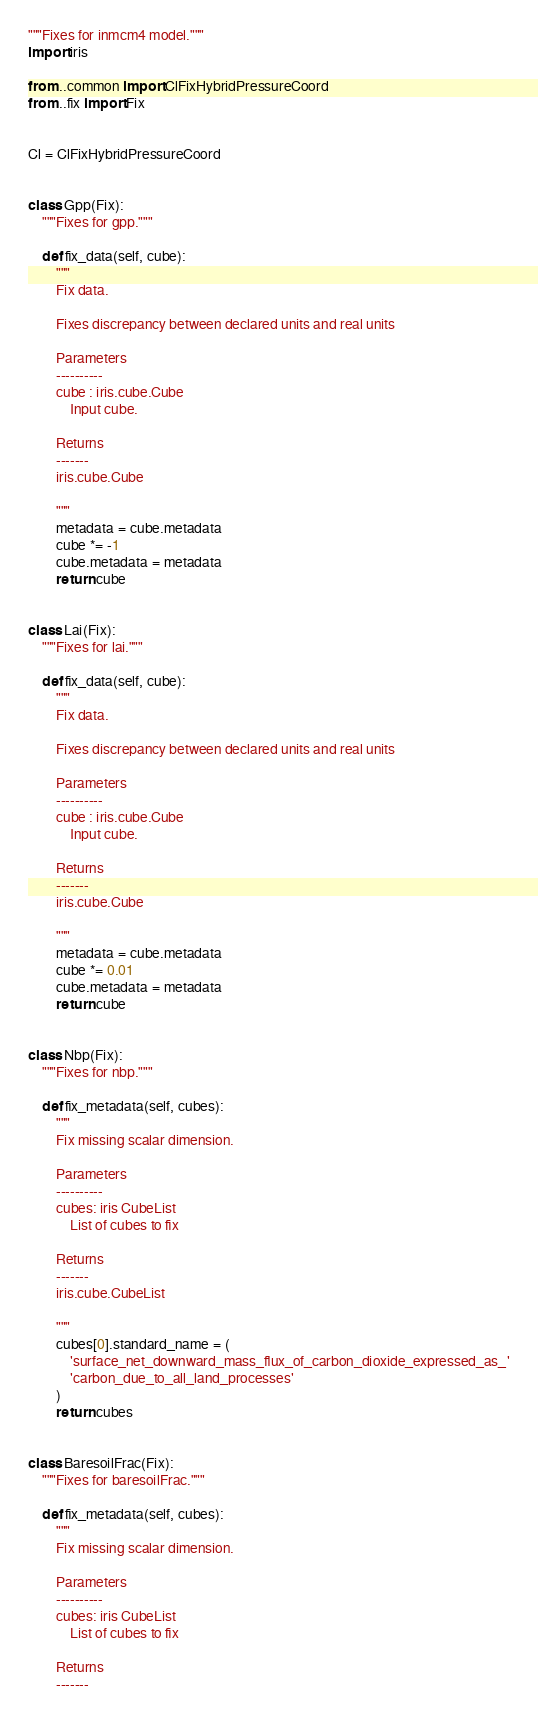<code> <loc_0><loc_0><loc_500><loc_500><_Python_>"""Fixes for inmcm4 model."""
import iris

from ..common import ClFixHybridPressureCoord
from ..fix import Fix


Cl = ClFixHybridPressureCoord


class Gpp(Fix):
    """Fixes for gpp."""

    def fix_data(self, cube):
        """
        Fix data.

        Fixes discrepancy between declared units and real units

        Parameters
        ----------
        cube : iris.cube.Cube
            Input cube.

        Returns
        -------
        iris.cube.Cube

        """
        metadata = cube.metadata
        cube *= -1
        cube.metadata = metadata
        return cube


class Lai(Fix):
    """Fixes for lai."""

    def fix_data(self, cube):
        """
        Fix data.

        Fixes discrepancy between declared units and real units

        Parameters
        ----------
        cube : iris.cube.Cube
            Input cube.

        Returns
        -------
        iris.cube.Cube

        """
        metadata = cube.metadata
        cube *= 0.01
        cube.metadata = metadata
        return cube


class Nbp(Fix):
    """Fixes for nbp."""

    def fix_metadata(self, cubes):
        """
        Fix missing scalar dimension.

        Parameters
        ----------
        cubes: iris CubeList
            List of cubes to fix

        Returns
        -------
        iris.cube.CubeList

        """
        cubes[0].standard_name = (
            'surface_net_downward_mass_flux_of_carbon_dioxide_expressed_as_'
            'carbon_due_to_all_land_processes'
        )
        return cubes


class BaresoilFrac(Fix):
    """Fixes for baresoilFrac."""

    def fix_metadata(self, cubes):
        """
        Fix missing scalar dimension.

        Parameters
        ----------
        cubes: iris CubeList
            List of cubes to fix

        Returns
        -------</code> 